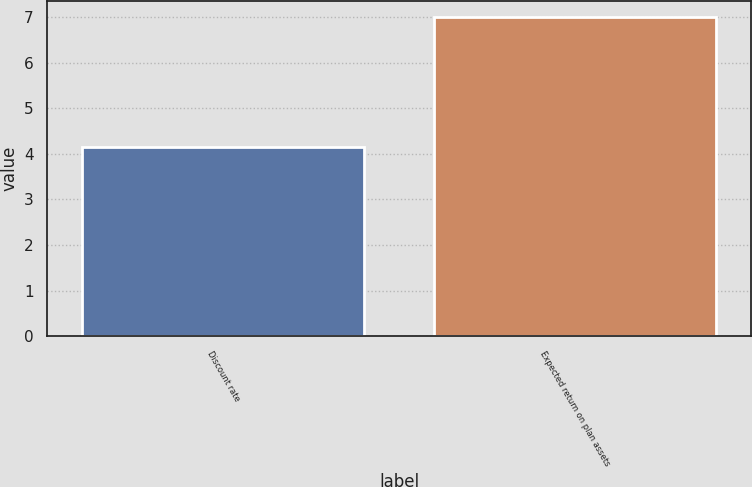<chart> <loc_0><loc_0><loc_500><loc_500><bar_chart><fcel>Discount rate<fcel>Expected return on plan assets<nl><fcel>4.15<fcel>7<nl></chart> 